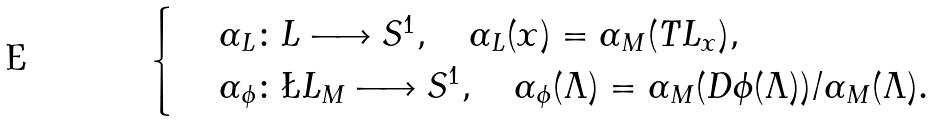Convert formula to latex. <formula><loc_0><loc_0><loc_500><loc_500>\begin{cases} & \, \alpha _ { L } \colon L \longrightarrow S ^ { 1 } , \quad \alpha _ { L } ( x ) = \alpha _ { M } ( T L _ { x } ) , \\ & \, \alpha _ { \phi } \colon \L L _ { M } \longrightarrow S ^ { 1 } , \quad \alpha _ { \phi } ( \Lambda ) = \alpha _ { M } ( D \phi ( \Lambda ) ) / \alpha _ { M } ( \Lambda ) . \end{cases}</formula> 